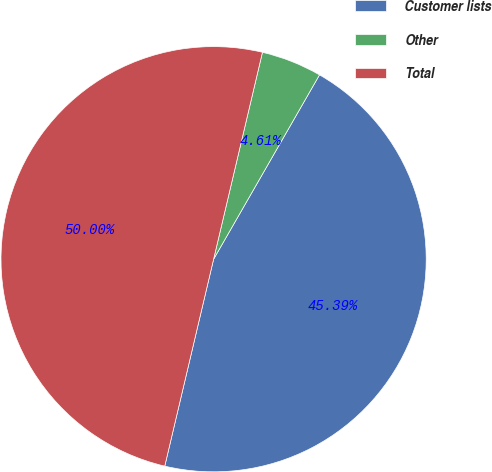Convert chart to OTSL. <chart><loc_0><loc_0><loc_500><loc_500><pie_chart><fcel>Customer lists<fcel>Other<fcel>Total<nl><fcel>45.39%<fcel>4.61%<fcel>50.0%<nl></chart> 